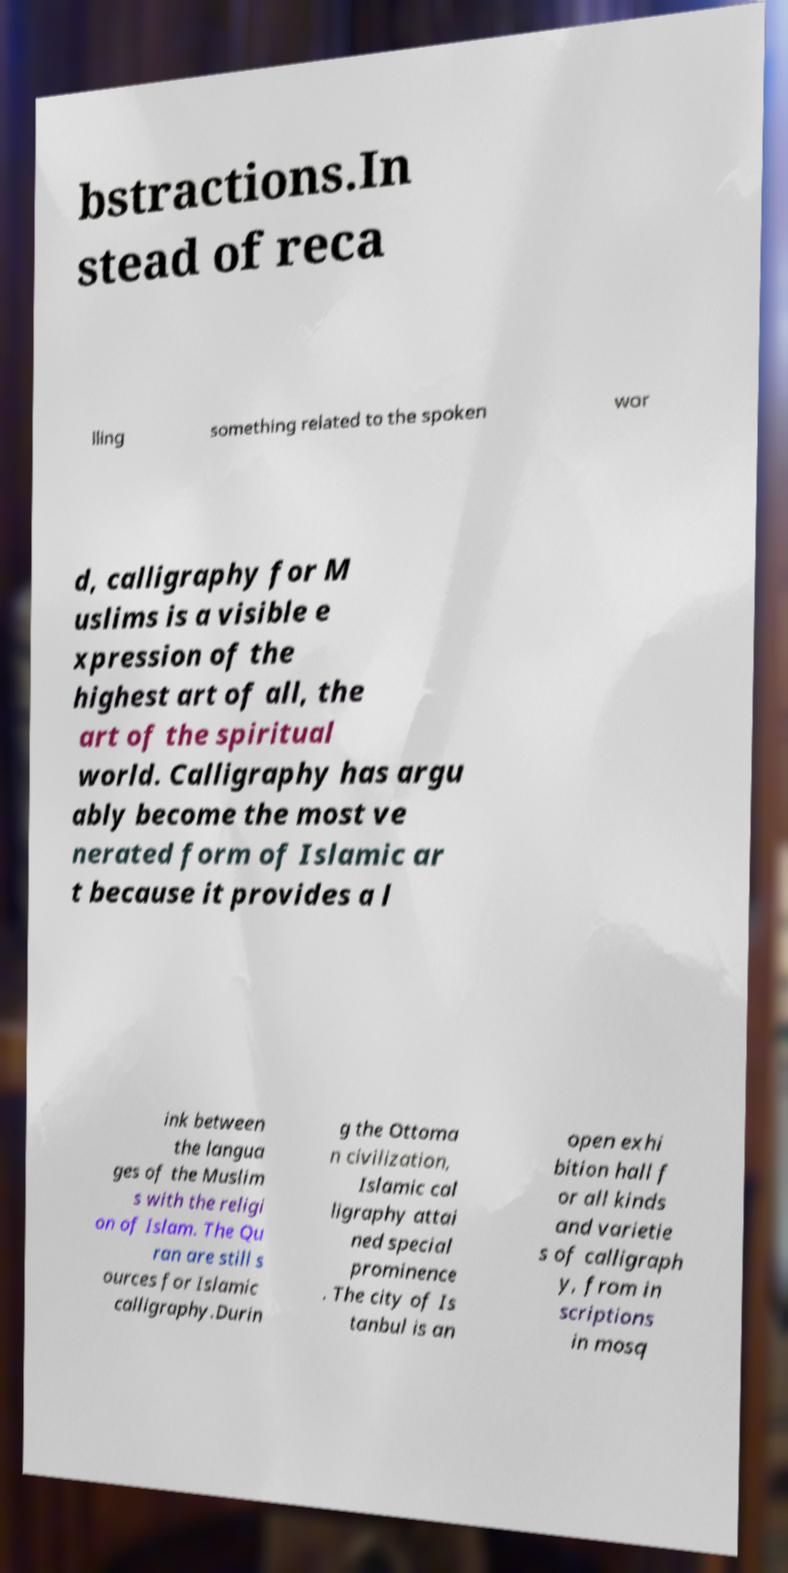What messages or text are displayed in this image? I need them in a readable, typed format. bstractions.In stead of reca lling something related to the spoken wor d, calligraphy for M uslims is a visible e xpression of the highest art of all, the art of the spiritual world. Calligraphy has argu ably become the most ve nerated form of Islamic ar t because it provides a l ink between the langua ges of the Muslim s with the religi on of Islam. The Qu ran are still s ources for Islamic calligraphy.Durin g the Ottoma n civilization, Islamic cal ligraphy attai ned special prominence . The city of Is tanbul is an open exhi bition hall f or all kinds and varietie s of calligraph y, from in scriptions in mosq 